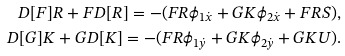Convert formula to latex. <formula><loc_0><loc_0><loc_500><loc_500>D [ F ] R + F D [ R ] = - ( F R \phi _ { 1 \dot { x } } + G K \phi _ { 2 \dot { x } } + F R S ) , \\ D [ G ] K + G D [ K ] = - ( F R \phi _ { 1 \dot { y } } + G K \phi _ { 2 \dot { y } } + G K U ) .</formula> 